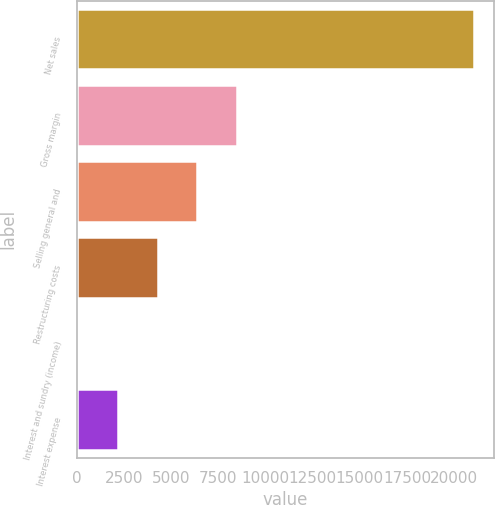Convert chart to OTSL. <chart><loc_0><loc_0><loc_500><loc_500><bar_chart><fcel>Net sales<fcel>Gross margin<fcel>Selling general and<fcel>Restructuring costs<fcel>Interest and sundry (income)<fcel>Interest expense<nl><fcel>21037<fcel>8479.6<fcel>6386.7<fcel>4293.8<fcel>108<fcel>2200.9<nl></chart> 